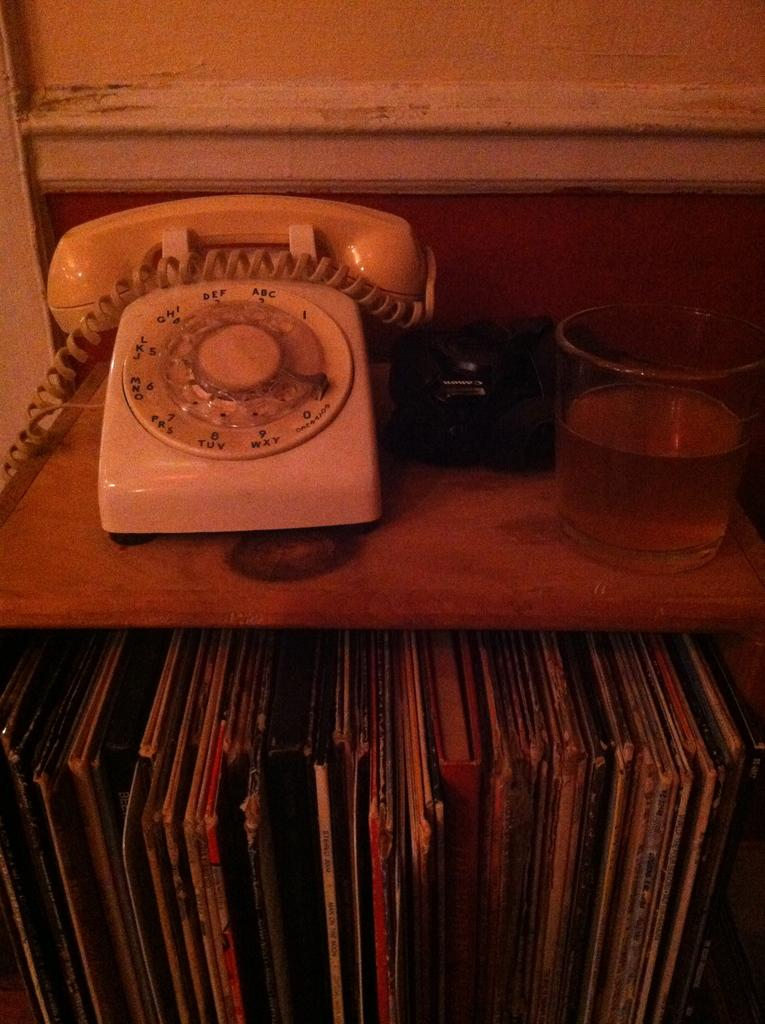<image>
Relay a brief, clear account of the picture shown. On a rotary phone, the number 2 corresponds with the letters ABC. 